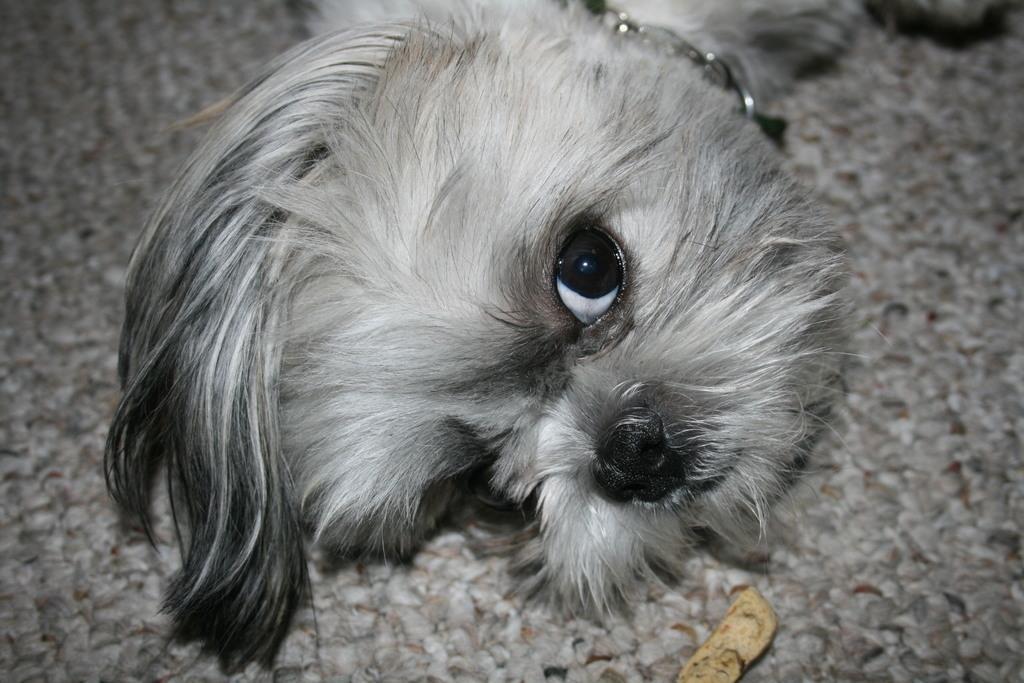Can you describe this image briefly? In this image a dog is lying on the cloth. Bottom of the image there is an object on the cloth. The dog is having a chain. 